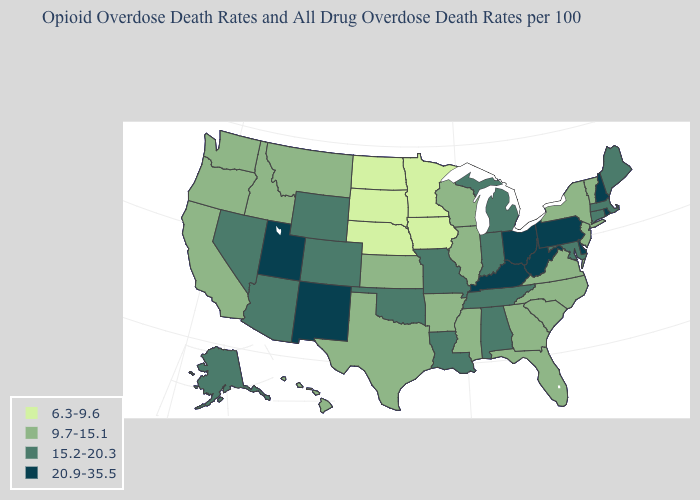Which states hav the highest value in the MidWest?
Quick response, please. Ohio. What is the value of Virginia?
Short answer required. 9.7-15.1. Which states have the highest value in the USA?
Short answer required. Delaware, Kentucky, New Hampshire, New Mexico, Ohio, Pennsylvania, Rhode Island, Utah, West Virginia. What is the value of North Dakota?
Concise answer only. 6.3-9.6. How many symbols are there in the legend?
Concise answer only. 4. What is the value of Hawaii?
Give a very brief answer. 9.7-15.1. Does Colorado have the highest value in the USA?
Keep it brief. No. What is the value of Nevada?
Write a very short answer. 15.2-20.3. What is the value of Idaho?
Give a very brief answer. 9.7-15.1. Among the states that border Nevada , which have the lowest value?
Be succinct. California, Idaho, Oregon. What is the highest value in the USA?
Keep it brief. 20.9-35.5. Name the states that have a value in the range 20.9-35.5?
Give a very brief answer. Delaware, Kentucky, New Hampshire, New Mexico, Ohio, Pennsylvania, Rhode Island, Utah, West Virginia. Name the states that have a value in the range 6.3-9.6?
Concise answer only. Iowa, Minnesota, Nebraska, North Dakota, South Dakota. 